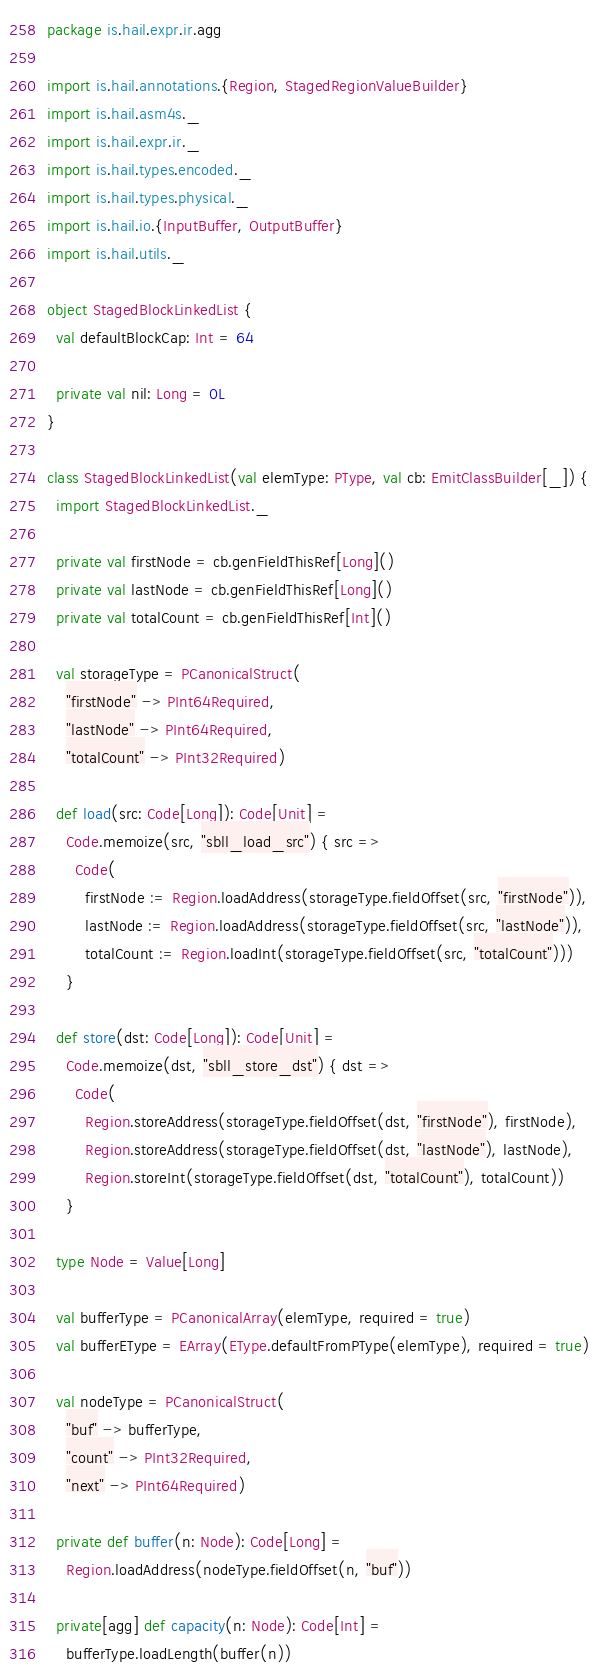<code> <loc_0><loc_0><loc_500><loc_500><_Scala_>package is.hail.expr.ir.agg

import is.hail.annotations.{Region, StagedRegionValueBuilder}
import is.hail.asm4s._
import is.hail.expr.ir._
import is.hail.types.encoded._
import is.hail.types.physical._
import is.hail.io.{InputBuffer, OutputBuffer}
import is.hail.utils._

object StagedBlockLinkedList {
  val defaultBlockCap: Int = 64

  private val nil: Long = 0L
}

class StagedBlockLinkedList(val elemType: PType, val cb: EmitClassBuilder[_]) {
  import StagedBlockLinkedList._

  private val firstNode = cb.genFieldThisRef[Long]()
  private val lastNode = cb.genFieldThisRef[Long]()
  private val totalCount = cb.genFieldThisRef[Int]()

  val storageType = PCanonicalStruct(
    "firstNode" -> PInt64Required,
    "lastNode" -> PInt64Required,
    "totalCount" -> PInt32Required)

  def load(src: Code[Long]): Code[Unit] =
    Code.memoize(src, "sbll_load_src") { src =>
      Code(
        firstNode := Region.loadAddress(storageType.fieldOffset(src, "firstNode")),
        lastNode := Region.loadAddress(storageType.fieldOffset(src, "lastNode")),
        totalCount := Region.loadInt(storageType.fieldOffset(src, "totalCount")))
    }

  def store(dst: Code[Long]): Code[Unit] =
    Code.memoize(dst, "sbll_store_dst") { dst =>
      Code(
        Region.storeAddress(storageType.fieldOffset(dst, "firstNode"), firstNode),
        Region.storeAddress(storageType.fieldOffset(dst, "lastNode"), lastNode),
        Region.storeInt(storageType.fieldOffset(dst, "totalCount"), totalCount))
    }

  type Node = Value[Long]

  val bufferType = PCanonicalArray(elemType, required = true)
  val bufferEType = EArray(EType.defaultFromPType(elemType), required = true)

  val nodeType = PCanonicalStruct(
    "buf" -> bufferType,
    "count" -> PInt32Required,
    "next" -> PInt64Required)

  private def buffer(n: Node): Code[Long] =
    Region.loadAddress(nodeType.fieldOffset(n, "buf"))

  private[agg] def capacity(n: Node): Code[Int] =
    bufferType.loadLength(buffer(n))
</code> 